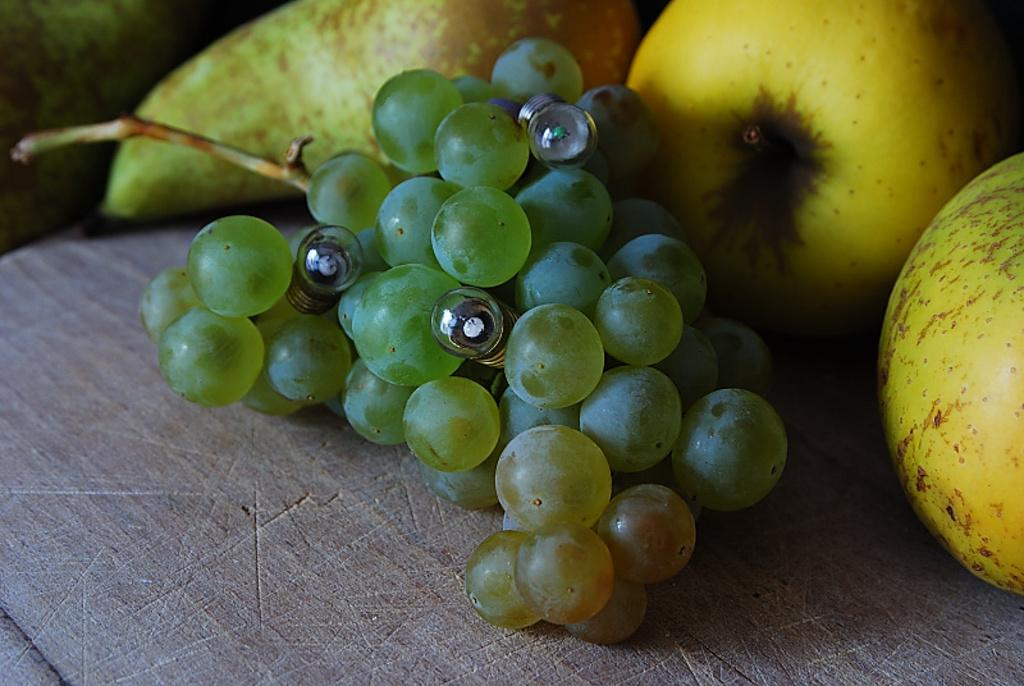What type of food is present in the image? There are fruits in the image. What colors can be seen on the fruits? The fruits have green, yellow, and brown colors. What is the surface on which the fruits are placed? The fruits are on a brown and ash color surface. What type of cable is used to hold the passenger in the image? There is no cable or passenger present in the image; it features fruits on a surface. 